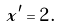Convert formula to latex. <formula><loc_0><loc_0><loc_500><loc_500>x ^ { \prime } = 2 \, .</formula> 